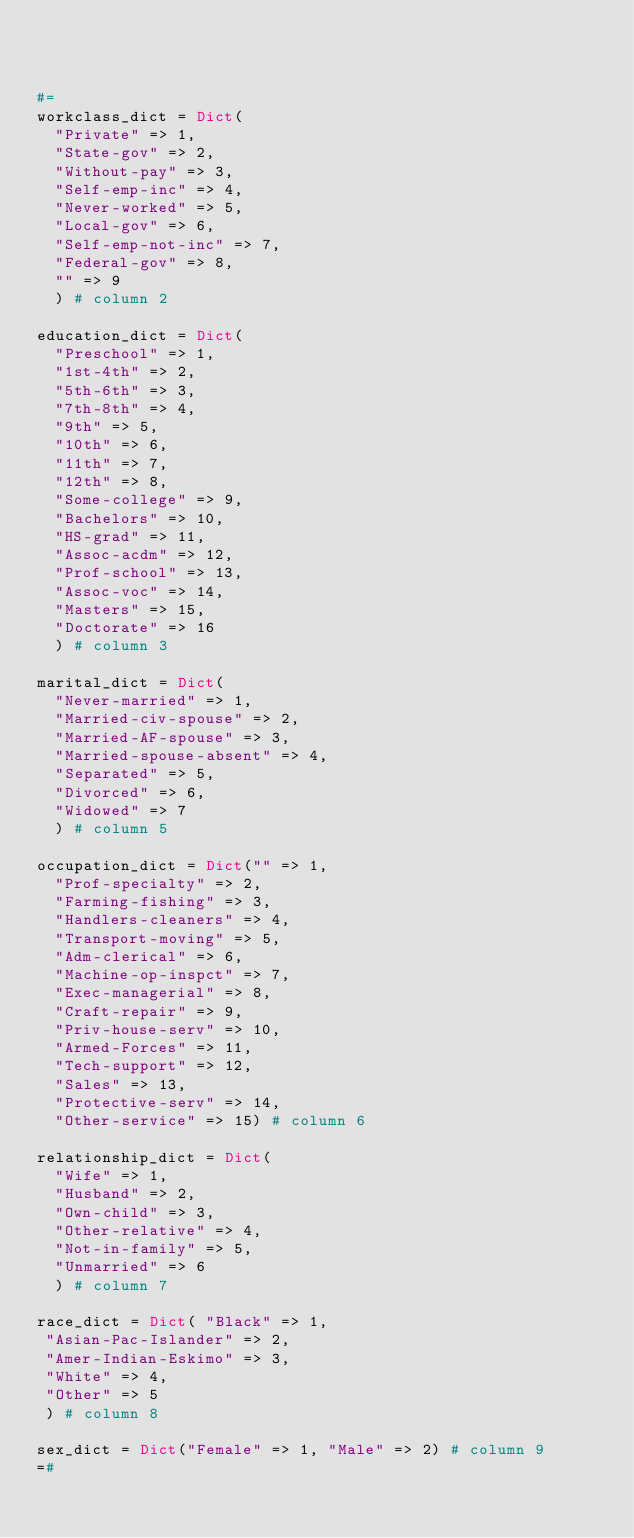Convert code to text. <code><loc_0><loc_0><loc_500><loc_500><_Julia_>


#=
workclass_dict = Dict(
  "Private" => 1,
  "State-gov" => 2,
  "Without-pay" => 3,
  "Self-emp-inc" => 4,
  "Never-worked" => 5,
  "Local-gov" => 6,
  "Self-emp-not-inc" => 7,
  "Federal-gov" => 8,
  "" => 9
  ) # column 2

education_dict = Dict(
  "Preschool" => 1,
  "1st-4th" => 2,
  "5th-6th" => 3,
  "7th-8th" => 4,
  "9th" => 5,
  "10th" => 6,
  "11th" => 7,
  "12th" => 8,
  "Some-college" => 9,
  "Bachelors" => 10,
  "HS-grad" => 11,
  "Assoc-acdm" => 12,
  "Prof-school" => 13,
  "Assoc-voc" => 14,
  "Masters" => 15,
  "Doctorate" => 16
  ) # column 3

marital_dict = Dict(
  "Never-married" => 1,
  "Married-civ-spouse" => 2,
  "Married-AF-spouse" => 3,
  "Married-spouse-absent" => 4,
  "Separated" => 5,
  "Divorced" => 6,
  "Widowed" => 7
  ) # column 5

occupation_dict = Dict("" => 1,
  "Prof-specialty" => 2,
  "Farming-fishing" => 3,
  "Handlers-cleaners" => 4,
  "Transport-moving" => 5,
  "Adm-clerical" => 6,
  "Machine-op-inspct" => 7,
  "Exec-managerial" => 8,
  "Craft-repair" => 9,
  "Priv-house-serv" => 10,
  "Armed-Forces" => 11,
  "Tech-support" => 12,
  "Sales" => 13,
  "Protective-serv" => 14,
  "Other-service" => 15) # column 6

relationship_dict = Dict(
  "Wife" => 1,
  "Husband" => 2,
  "Own-child" => 3,
  "Other-relative" => 4,
  "Not-in-family" => 5,
  "Unmarried" => 6
  ) # column 7

race_dict = Dict( "Black" => 1,
 "Asian-Pac-Islander" => 2,
 "Amer-Indian-Eskimo" => 3,
 "White" => 4,
 "Other" => 5
 ) # column 8

sex_dict = Dict("Female" => 1, "Male" => 2) # column 9
=#
</code> 